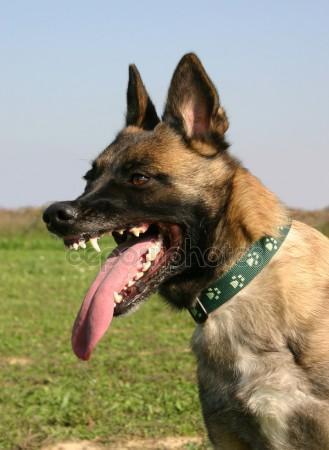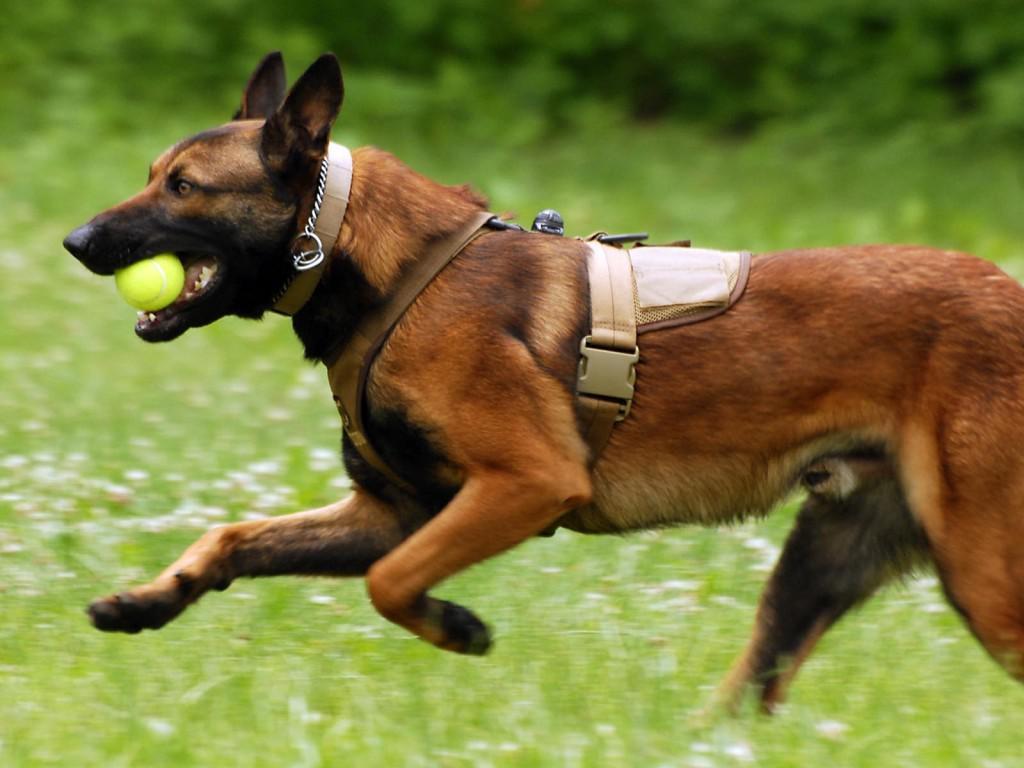The first image is the image on the left, the second image is the image on the right. For the images shown, is this caption "the anilmal's tongue is extended in one of the images" true? Answer yes or no. Yes. The first image is the image on the left, the second image is the image on the right. Assess this claim about the two images: "One of the dogs is carrying a toy in it's mouth.". Correct or not? Answer yes or no. Yes. 